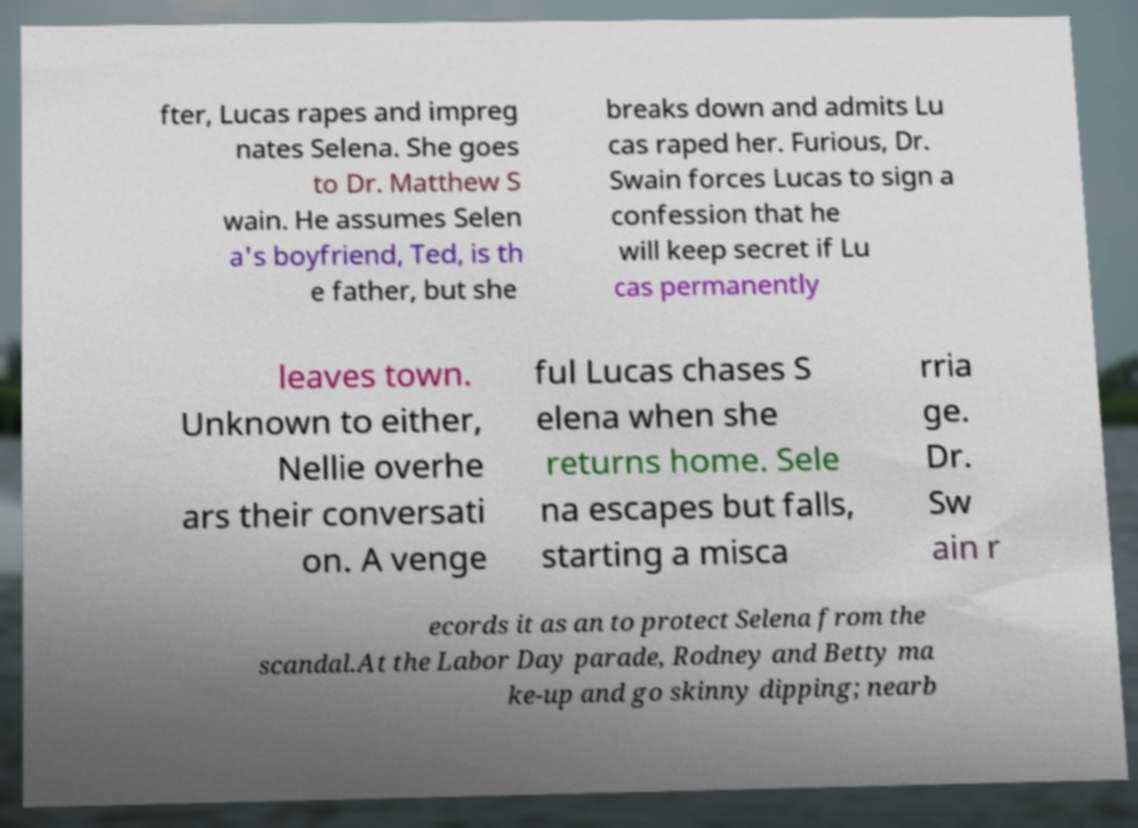Please identify and transcribe the text found in this image. fter, Lucas rapes and impreg nates Selena. She goes to Dr. Matthew S wain. He assumes Selen a's boyfriend, Ted, is th e father, but she breaks down and admits Lu cas raped her. Furious, Dr. Swain forces Lucas to sign a confession that he will keep secret if Lu cas permanently leaves town. Unknown to either, Nellie overhe ars their conversati on. A venge ful Lucas chases S elena when she returns home. Sele na escapes but falls, starting a misca rria ge. Dr. Sw ain r ecords it as an to protect Selena from the scandal.At the Labor Day parade, Rodney and Betty ma ke-up and go skinny dipping; nearb 